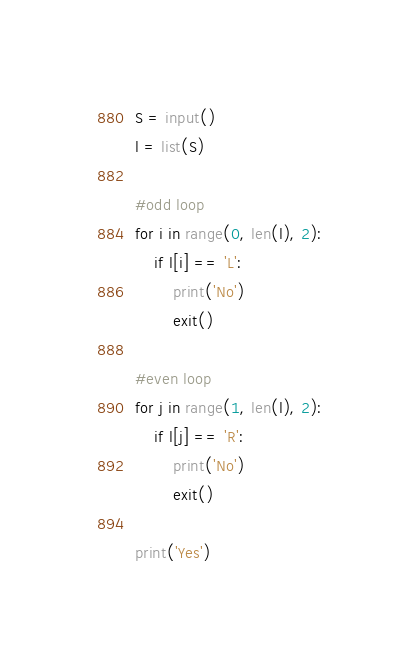<code> <loc_0><loc_0><loc_500><loc_500><_Python_>S = input()
l = list(S)

#odd loop
for i in range(0, len(l), 2):
    if l[i] == 'L':
        print('No')
        exit()

#even loop
for j in range(1, len(l), 2):
    if l[j] == 'R':
        print('No')
        exit()

print('Yes')</code> 